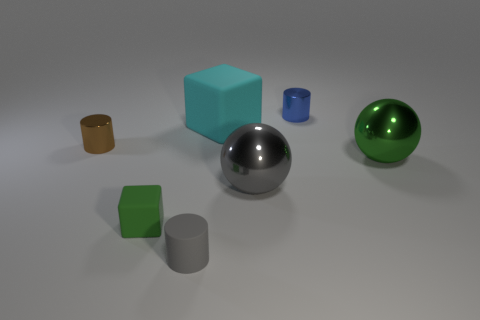Subtract all metal cylinders. How many cylinders are left? 1 Add 1 tiny blue metal objects. How many objects exist? 8 Subtract all large red cylinders. Subtract all small gray rubber things. How many objects are left? 6 Add 5 small blue cylinders. How many small blue cylinders are left? 6 Add 2 tiny brown metallic cubes. How many tiny brown metallic cubes exist? 2 Subtract 0 purple spheres. How many objects are left? 7 Subtract all spheres. How many objects are left? 5 